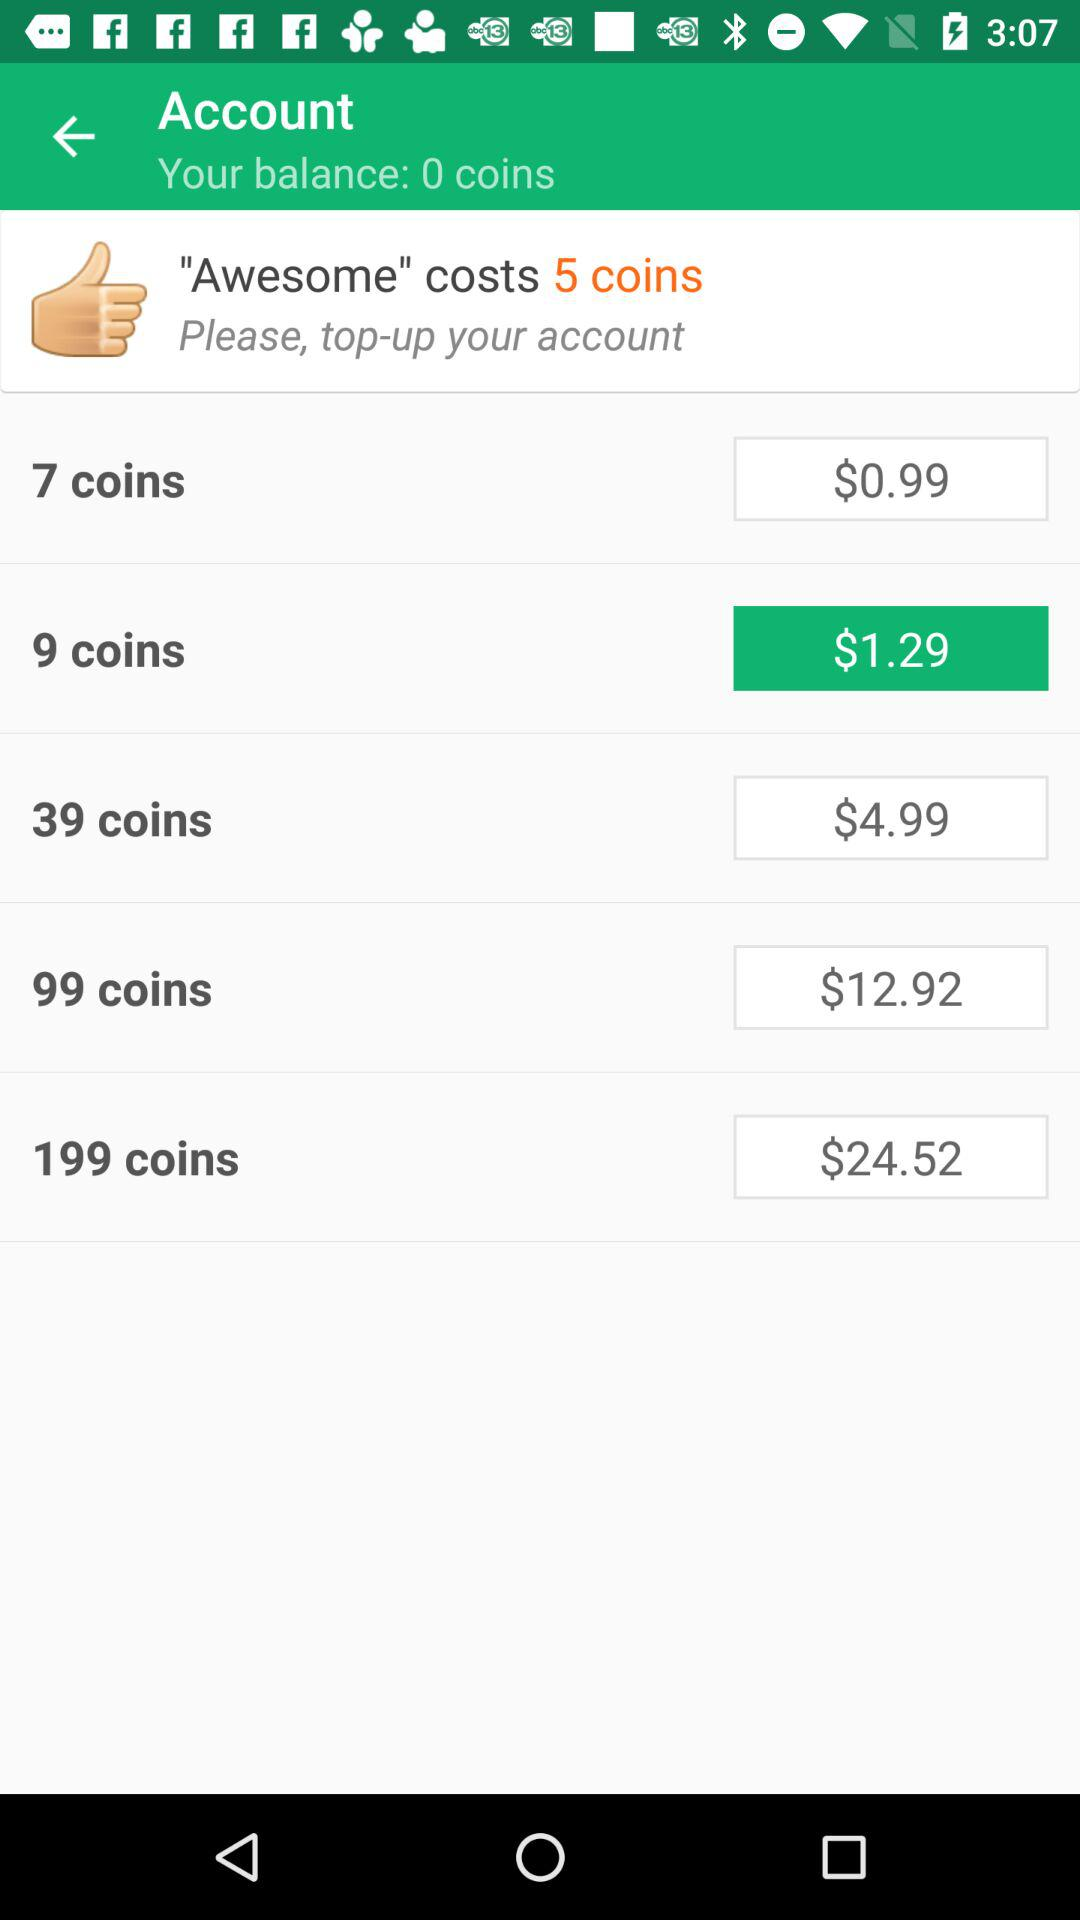How much would it cost to buy exactly 100 coins? The image does not provide an exact price for 100 coins, but you can approximate by combining the 99 coins package for $12.92 with a single coin from the 9 coins package, which costs $1.29. This would total approximately $14.21 for 100 coins, excluding any potential discounts or fees for separate transactions. 